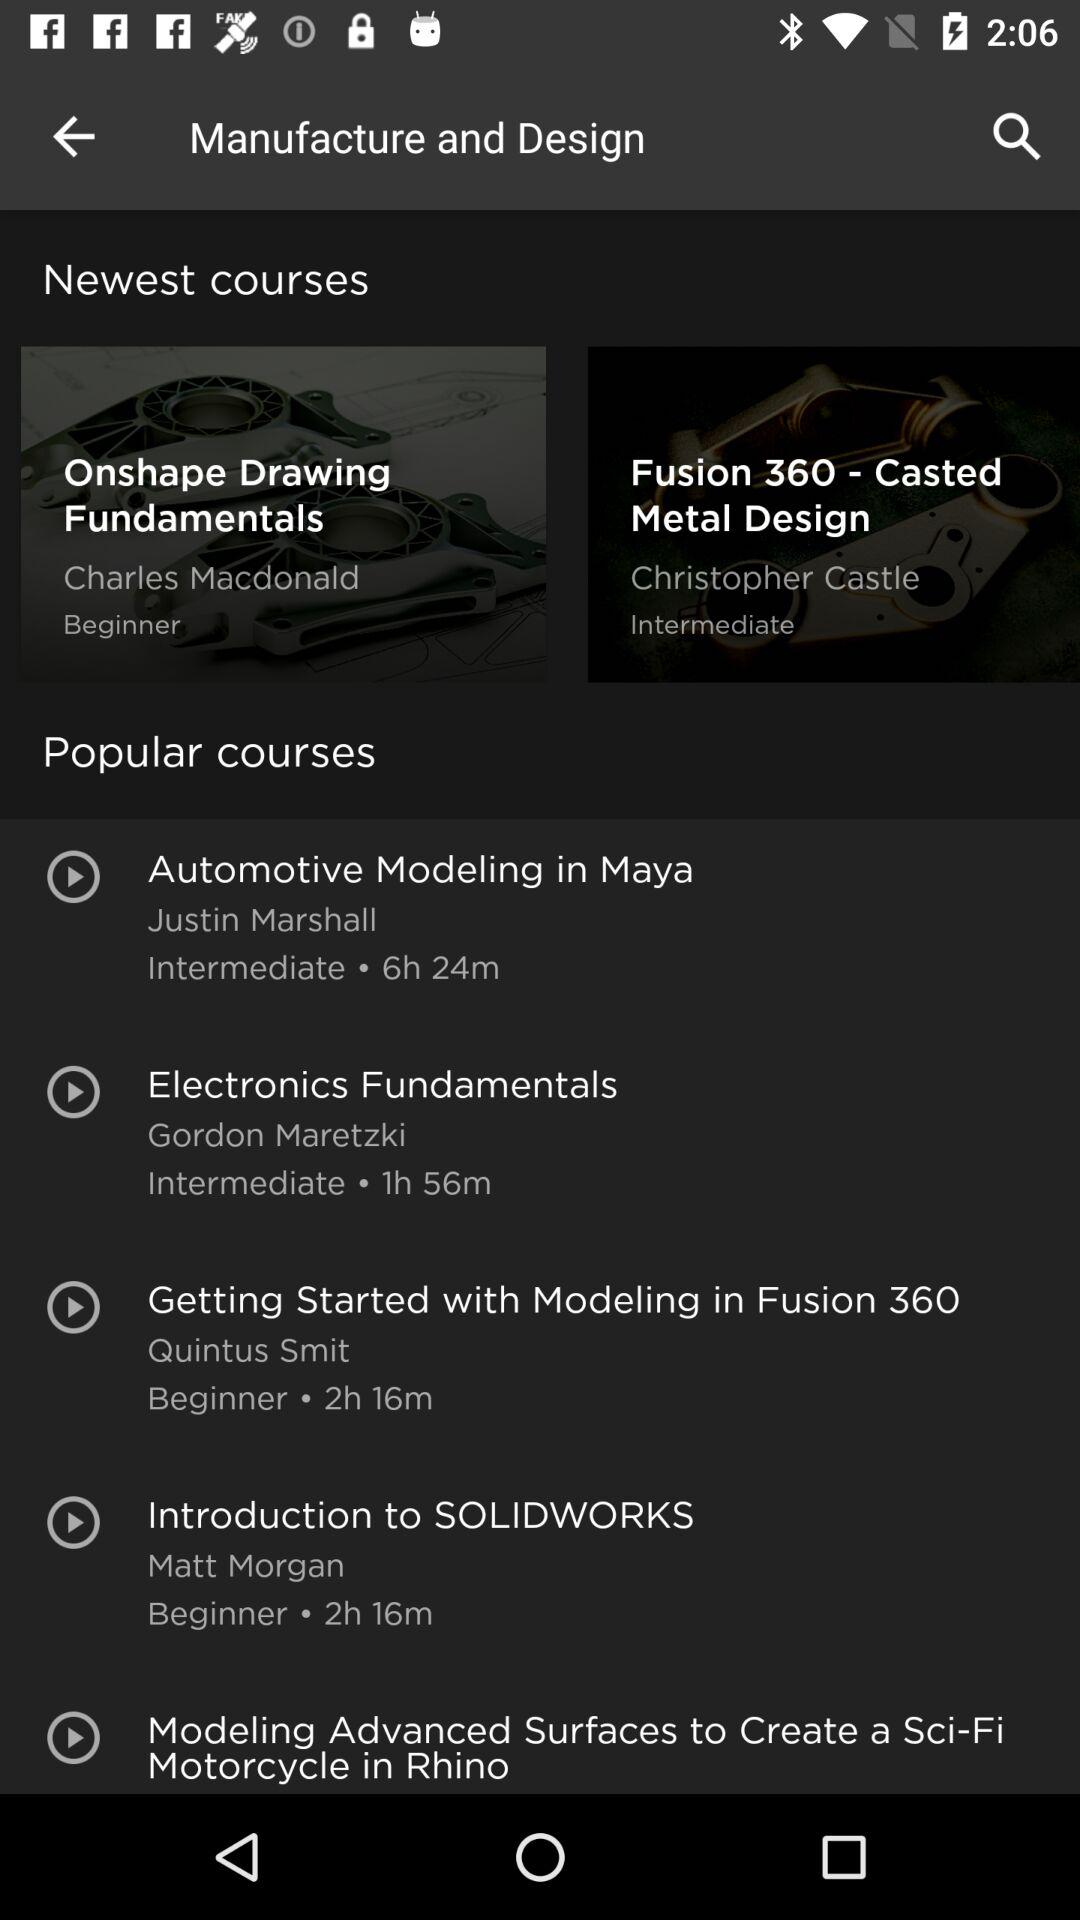Who's the author of "Electronics Fundamentals"? The author of "Electronics Fundamentals" is Gordon Maretzki. 